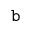Convert formula to latex. <formula><loc_0><loc_0><loc_500><loc_500>b</formula> 